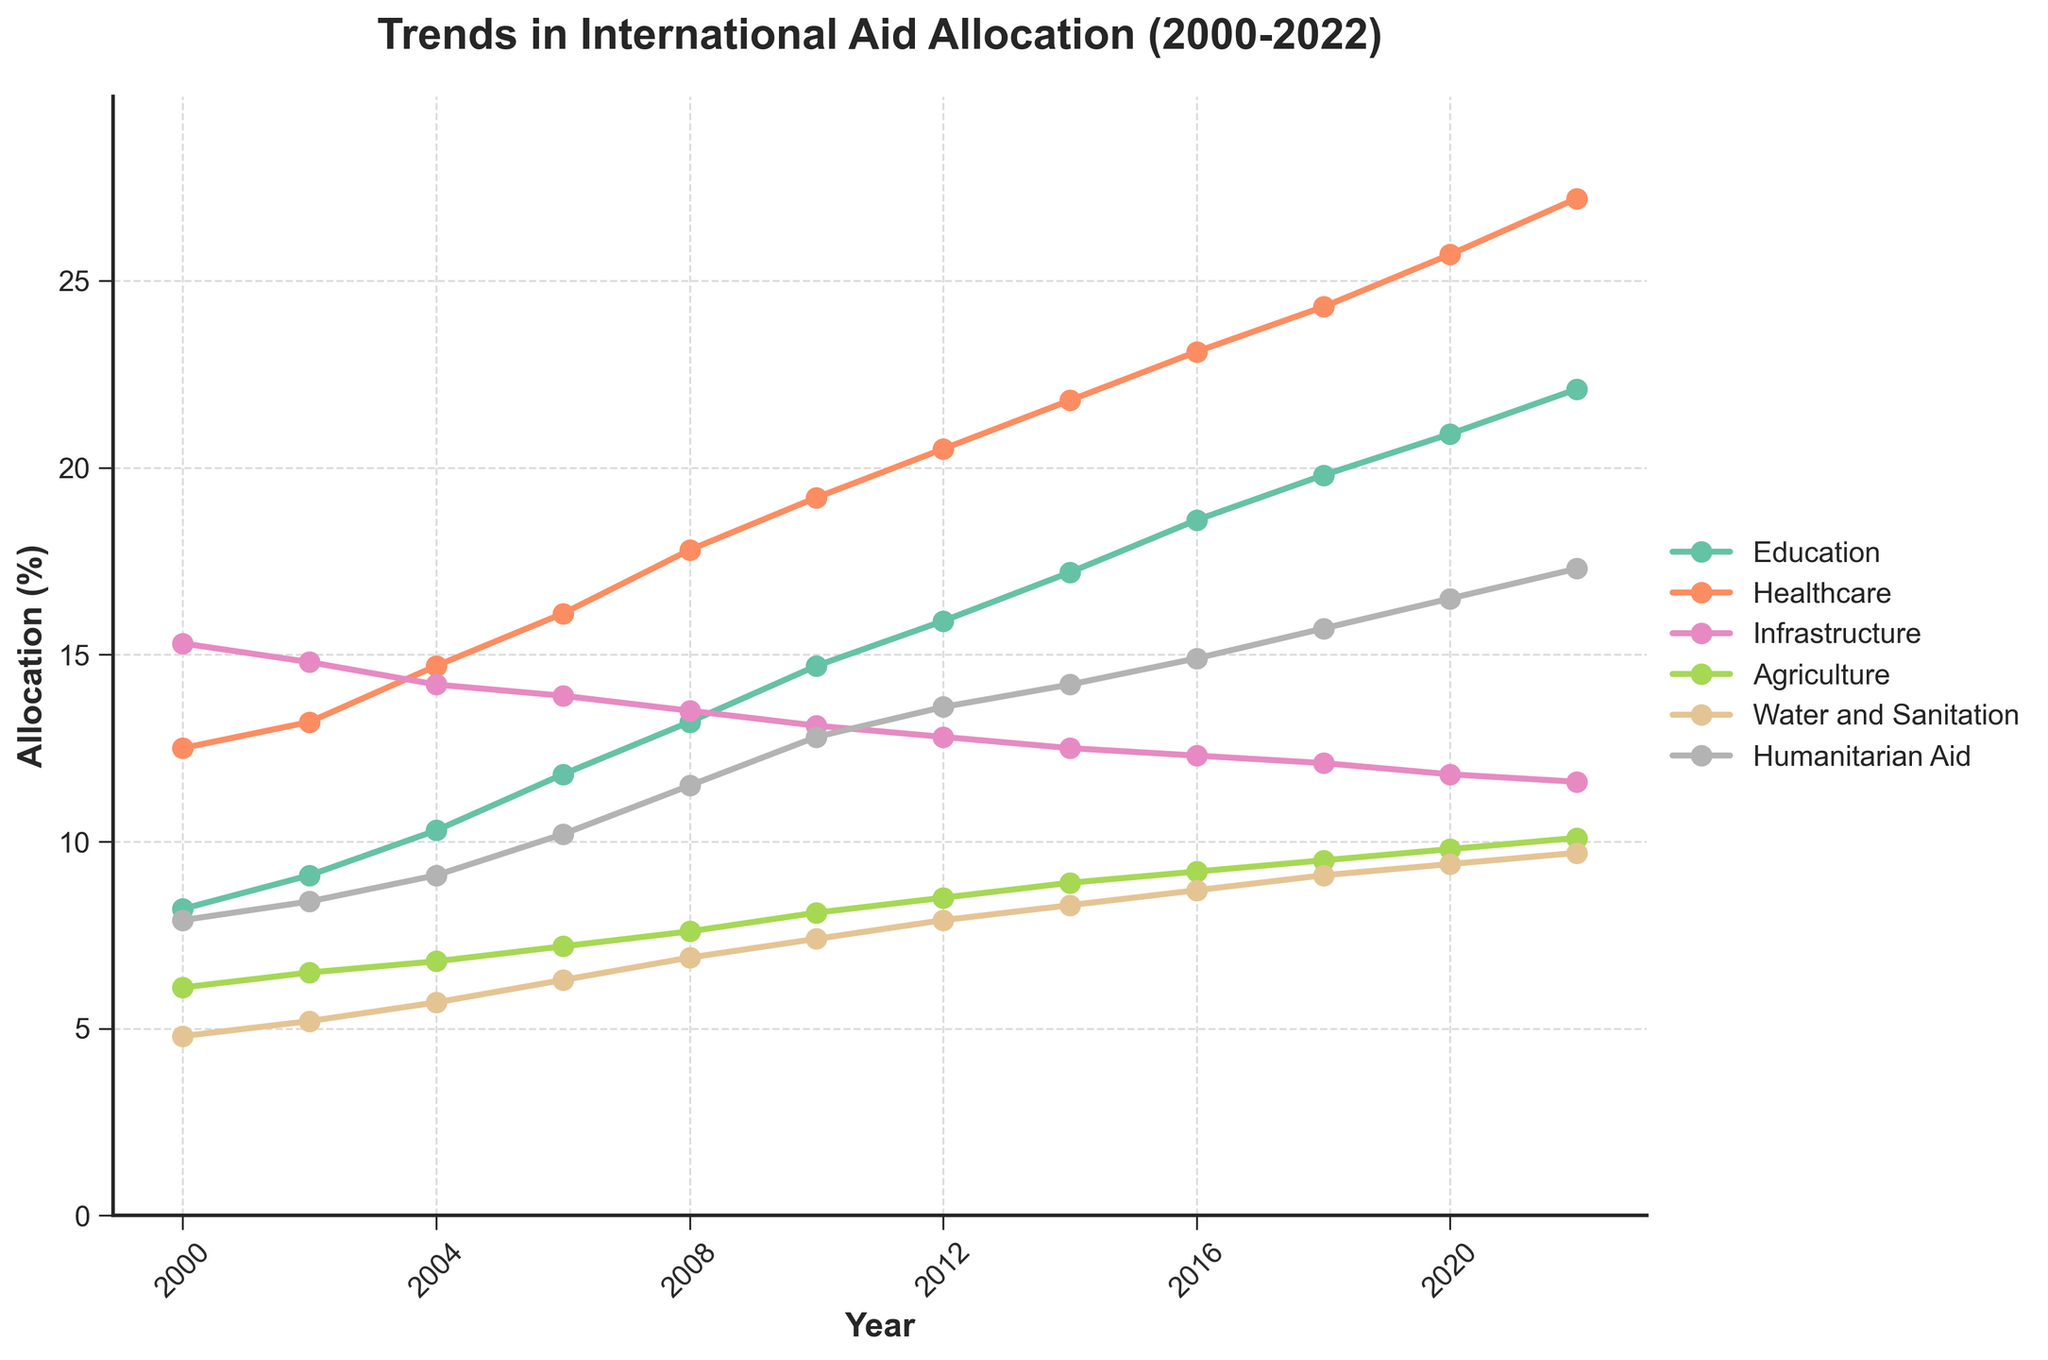What sector saw the highest increase in aid allocation from 2000 to 2022? To find this, calculate the difference between the 2022 and 2000 values for each sector. Education: 22.1 - 8.2 = 13.9, Healthcare: 27.2 - 12.5 = 14.7, Infrastructure: 11.6 - 15.3 = -3.7, Agriculture: 10.1 - 6.1 = 4.0, Water and Sanitation: 9.7 - 4.8 = 4.9, Humanitarian Aid: 17.3 - 7.9 = 9.4. Healthcare saw the highest increase.
Answer: Healthcare Which sector had the least aid allocation percentage in 2022? Refer to the 2022 data points for each sector. The values are Education: 22.1, Healthcare: 27.2, Infrastructure: 11.6, Agriculture: 10.1, Water and Sanitation: 9.7, Humanitarian Aid: 17.3. Water and Sanitation had the least allocation.
Answer: Water and Sanitation How does the trend of aid allocation in education compare to healthcare from 2000 to 2022? Both trends show a consistent increase over time. To compare them, look at the slope and end values: Education starts at 8.2 and ends at 22.1, while Healthcare starts at 12.5 and ends at 27.2. Healthcare's slope is steeper, indicating a larger and faster increase.
Answer: Healthcare increased faster Was there any sector whose aid allocation decreased over the period from 2000 to 2022? Look at the starting and ending values for any downtrend. Infrastructure in 2000 was 15.3 and ended at 11.6 in 2022, indicating a decrease.
Answer: Infrastructure What was the total aid allocation percentage across all sectors in 2006? Sum the 2006 values for each sector: Education: 11.8, Healthcare: 16.1, Infrastructure: 13.9, Agriculture: 7.2, Water and Sanitation: 6.3, Humanitarian Aid: 10.2. Total = 11.8 + 16.1 + 13.9 + 7.2 + 6.3 + 10.2 = 65.5
Answer: 65.5 Compare the aid allocation for Humanitarian Aid and Agriculture in 2010. Which was higher and by how much? 2010 values are Humanitarian Aid: 12.8, Agriculture: 8.1. Difference is 12.8 - 8.1 = 4.7. Humanitarian Aid was higher by 4.7.
Answer: Humanitarian Aid by 4.7 In which year did Water and Sanitation reach at least 9% in aid allocation? Look through the data for Water and Sanitation. It first reached at least 9% in 2018.
Answer: 2018 Calculate the average aid allocation for Infrastructure from 2000 to 2022. Values are 15.3, 14.8, 14.2, 13.9, 13.5, 13.1, 12.8, 12.5, 12.3, 12.1, 11.8, 11.6. Sum = 157.8. Average = 157.8 / 12 = 13.15
Answer: 13.15 